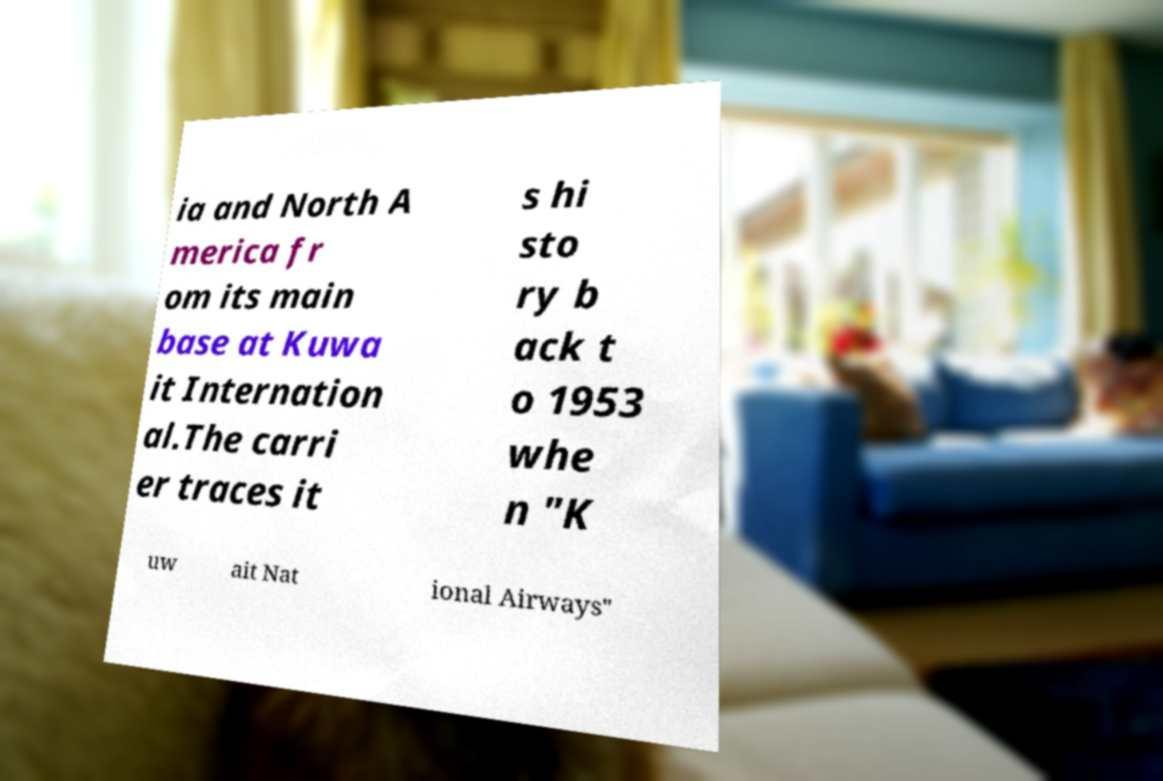Could you extract and type out the text from this image? ia and North A merica fr om its main base at Kuwa it Internation al.The carri er traces it s hi sto ry b ack t o 1953 whe n "K uw ait Nat ional Airways" 